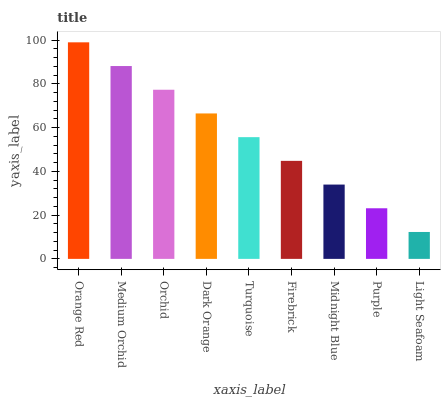Is Light Seafoam the minimum?
Answer yes or no. Yes. Is Orange Red the maximum?
Answer yes or no. Yes. Is Medium Orchid the minimum?
Answer yes or no. No. Is Medium Orchid the maximum?
Answer yes or no. No. Is Orange Red greater than Medium Orchid?
Answer yes or no. Yes. Is Medium Orchid less than Orange Red?
Answer yes or no. Yes. Is Medium Orchid greater than Orange Red?
Answer yes or no. No. Is Orange Red less than Medium Orchid?
Answer yes or no. No. Is Turquoise the high median?
Answer yes or no. Yes. Is Turquoise the low median?
Answer yes or no. Yes. Is Midnight Blue the high median?
Answer yes or no. No. Is Light Seafoam the low median?
Answer yes or no. No. 